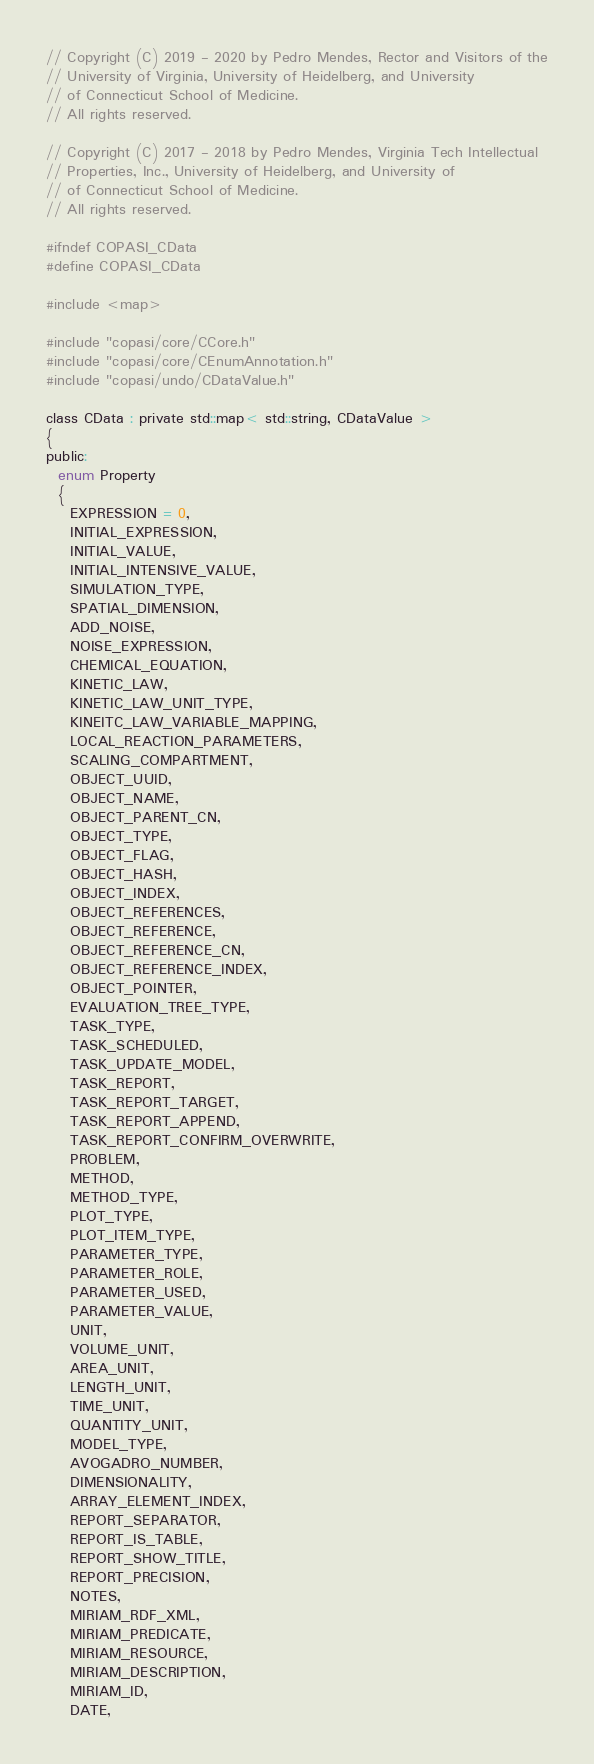<code> <loc_0><loc_0><loc_500><loc_500><_C_>// Copyright (C) 2019 - 2020 by Pedro Mendes, Rector and Visitors of the
// University of Virginia, University of Heidelberg, and University
// of Connecticut School of Medicine.
// All rights reserved.

// Copyright (C) 2017 - 2018 by Pedro Mendes, Virginia Tech Intellectual
// Properties, Inc., University of Heidelberg, and University of
// of Connecticut School of Medicine.
// All rights reserved.

#ifndef COPASI_CData
#define COPASI_CData

#include <map>

#include "copasi/core/CCore.h"
#include "copasi/core/CEnumAnnotation.h"
#include "copasi/undo/CDataValue.h"

class CData : private std::map< std::string, CDataValue >
{
public:
  enum Property
  {
    EXPRESSION = 0,
    INITIAL_EXPRESSION,
    INITIAL_VALUE,
    INITIAL_INTENSIVE_VALUE,
    SIMULATION_TYPE,
    SPATIAL_DIMENSION,
    ADD_NOISE,
    NOISE_EXPRESSION,
    CHEMICAL_EQUATION,
    KINETIC_LAW,
    KINETIC_LAW_UNIT_TYPE,
    KINEITC_LAW_VARIABLE_MAPPING,
    LOCAL_REACTION_PARAMETERS,
    SCALING_COMPARTMENT,
    OBJECT_UUID,
    OBJECT_NAME,
    OBJECT_PARENT_CN,
    OBJECT_TYPE,
    OBJECT_FLAG,
    OBJECT_HASH,
    OBJECT_INDEX,
    OBJECT_REFERENCES,
    OBJECT_REFERENCE,
    OBJECT_REFERENCE_CN,
    OBJECT_REFERENCE_INDEX,
    OBJECT_POINTER,
    EVALUATION_TREE_TYPE,
    TASK_TYPE,
    TASK_SCHEDULED,
    TASK_UPDATE_MODEL,
    TASK_REPORT,
    TASK_REPORT_TARGET,
    TASK_REPORT_APPEND,
    TASK_REPORT_CONFIRM_OVERWRITE,
    PROBLEM,
    METHOD,
    METHOD_TYPE,
    PLOT_TYPE,
    PLOT_ITEM_TYPE,
    PARAMETER_TYPE,
    PARAMETER_ROLE,
    PARAMETER_USED,
    PARAMETER_VALUE,
    UNIT,
    VOLUME_UNIT,
    AREA_UNIT,
    LENGTH_UNIT,
    TIME_UNIT,
    QUANTITY_UNIT,
    MODEL_TYPE,
    AVOGADRO_NUMBER,
    DIMENSIONALITY,
    ARRAY_ELEMENT_INDEX,
    REPORT_SEPARATOR,
    REPORT_IS_TABLE,
    REPORT_SHOW_TITLE,
    REPORT_PRECISION,
    NOTES,
    MIRIAM_RDF_XML,
    MIRIAM_PREDICATE,
    MIRIAM_RESOURCE,
    MIRIAM_DESCRIPTION,
    MIRIAM_ID,
    DATE,</code> 